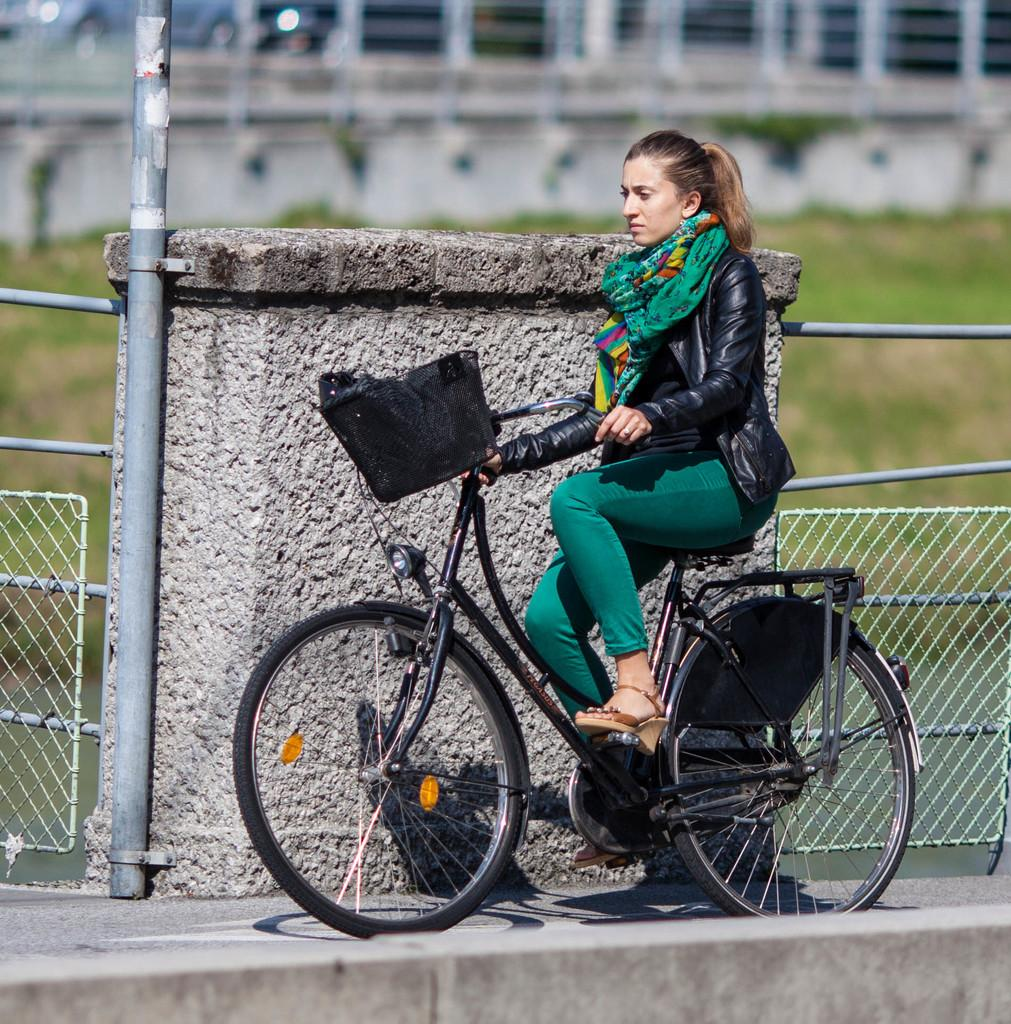Who is the main subject in the image? There is a girl in the image. What is the girl doing in the image? The girl is riding a bicycle. What can be seen in the background of the image? There is a wall, fencing, and grass visible in the background of the image. What type of wealth is the girl accumulating while riding the bicycle in the image? There is no indication of wealth or any financial activity in the image; the girl is simply riding a bicycle. 